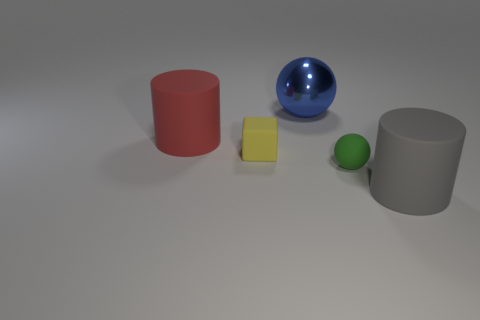What could be the potential practical uses for each of the objects shown in the image? The red cylinder might be used as a container or a stand, the blue sphere could serve as a decorative element, the yellow cube could function as a weight or a calibration block for measurement, and the grey cylinder could be a base for a lamp or a paper roll holder. 